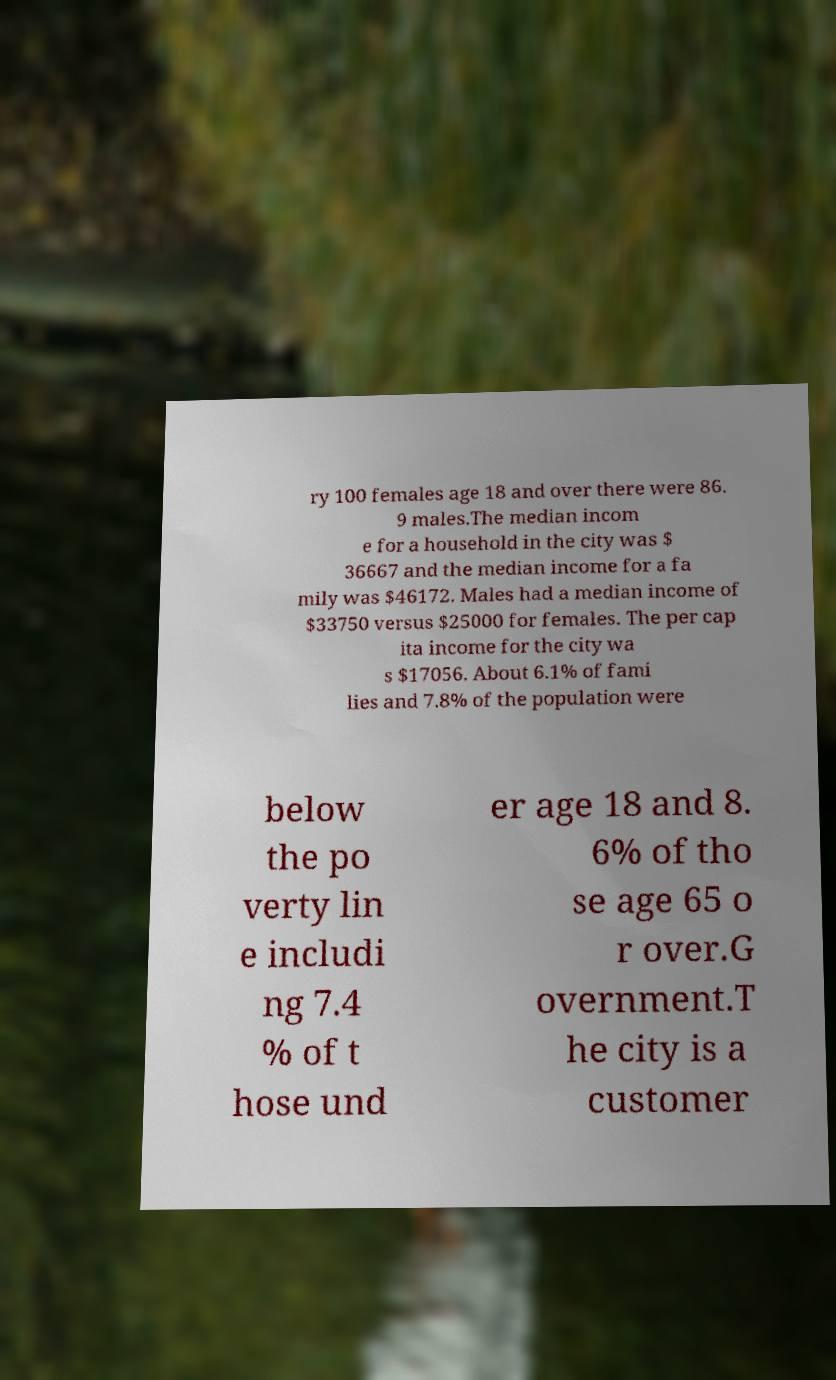Can you accurately transcribe the text from the provided image for me? ry 100 females age 18 and over there were 86. 9 males.The median incom e for a household in the city was $ 36667 and the median income for a fa mily was $46172. Males had a median income of $33750 versus $25000 for females. The per cap ita income for the city wa s $17056. About 6.1% of fami lies and 7.8% of the population were below the po verty lin e includi ng 7.4 % of t hose und er age 18 and 8. 6% of tho se age 65 o r over.G overnment.T he city is a customer 